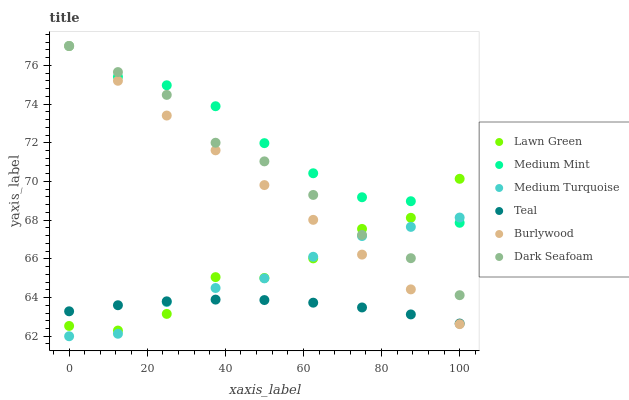Does Teal have the minimum area under the curve?
Answer yes or no. Yes. Does Medium Mint have the maximum area under the curve?
Answer yes or no. Yes. Does Lawn Green have the minimum area under the curve?
Answer yes or no. No. Does Lawn Green have the maximum area under the curve?
Answer yes or no. No. Is Burlywood the smoothest?
Answer yes or no. Yes. Is Lawn Green the roughest?
Answer yes or no. Yes. Is Medium Turquoise the smoothest?
Answer yes or no. No. Is Medium Turquoise the roughest?
Answer yes or no. No. Does Medium Turquoise have the lowest value?
Answer yes or no. Yes. Does Lawn Green have the lowest value?
Answer yes or no. No. Does Dark Seafoam have the highest value?
Answer yes or no. Yes. Does Lawn Green have the highest value?
Answer yes or no. No. Is Teal less than Medium Mint?
Answer yes or no. Yes. Is Medium Mint greater than Teal?
Answer yes or no. Yes. Does Dark Seafoam intersect Medium Turquoise?
Answer yes or no. Yes. Is Dark Seafoam less than Medium Turquoise?
Answer yes or no. No. Is Dark Seafoam greater than Medium Turquoise?
Answer yes or no. No. Does Teal intersect Medium Mint?
Answer yes or no. No. 